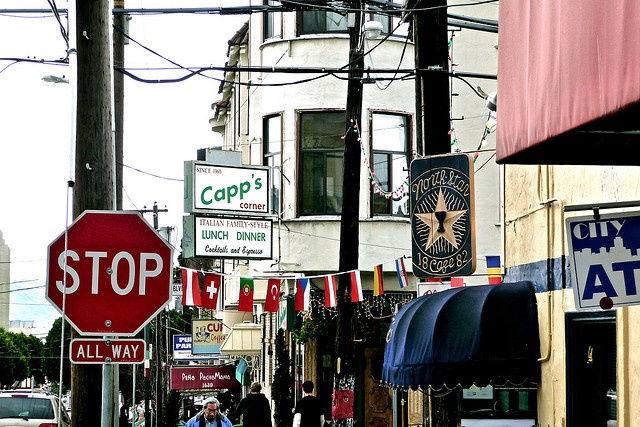Describe the objects in this image and their specific colors. I can see stop sign in white, maroon, darkgray, lightgray, and lightblue tones, car in white, teal, and black tones, people in white, black, gray, and maroon tones, people in white, black, gray, and olive tones, and people in white, black, lightblue, and gray tones in this image. 